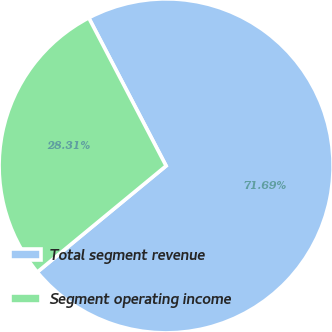<chart> <loc_0><loc_0><loc_500><loc_500><pie_chart><fcel>Total segment revenue<fcel>Segment operating income<nl><fcel>71.69%<fcel>28.31%<nl></chart> 